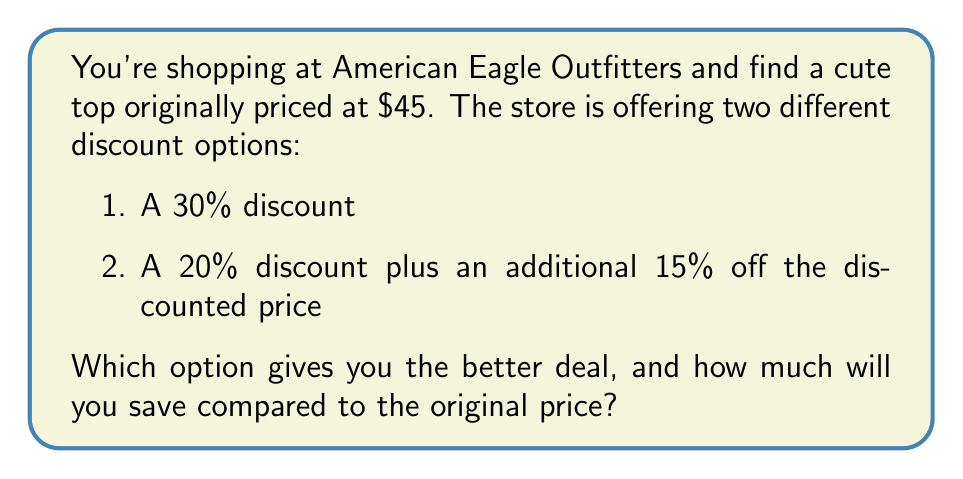Teach me how to tackle this problem. Let's calculate the final price for each option:

Option 1: 30% discount
1. Calculate the discount amount:
   $45 \times 0.30 = $13.50$
2. Subtract the discount from the original price:
   $45 - $13.50 = $31.50$

Option 2: 20% discount plus an additional 15% off
1. Calculate the price after the 20% discount:
   $45 \times (1 - 0.20) = $45 \times 0.80 = $36$
2. Apply the additional 15% discount to the new price:
   $36 \times (1 - 0.15) = $36 \times 0.85 = $30.60$

Compare the final prices:
Option 1: $31.50
Option 2: $30.60

Option 2 gives you the better deal.

To calculate the savings compared to the original price:
$45 - $30.60 = $14.40$
Answer: Option 2; $14.40 saved 